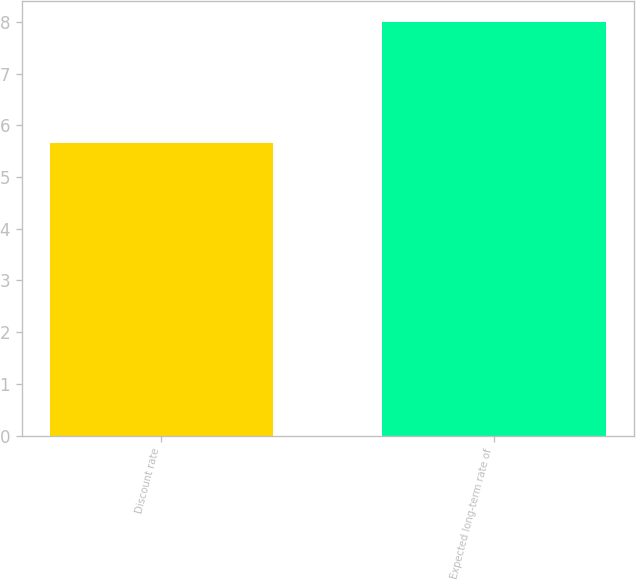Convert chart. <chart><loc_0><loc_0><loc_500><loc_500><bar_chart><fcel>Discount rate<fcel>Expected long-term rate of<nl><fcel>5.65<fcel>8<nl></chart> 